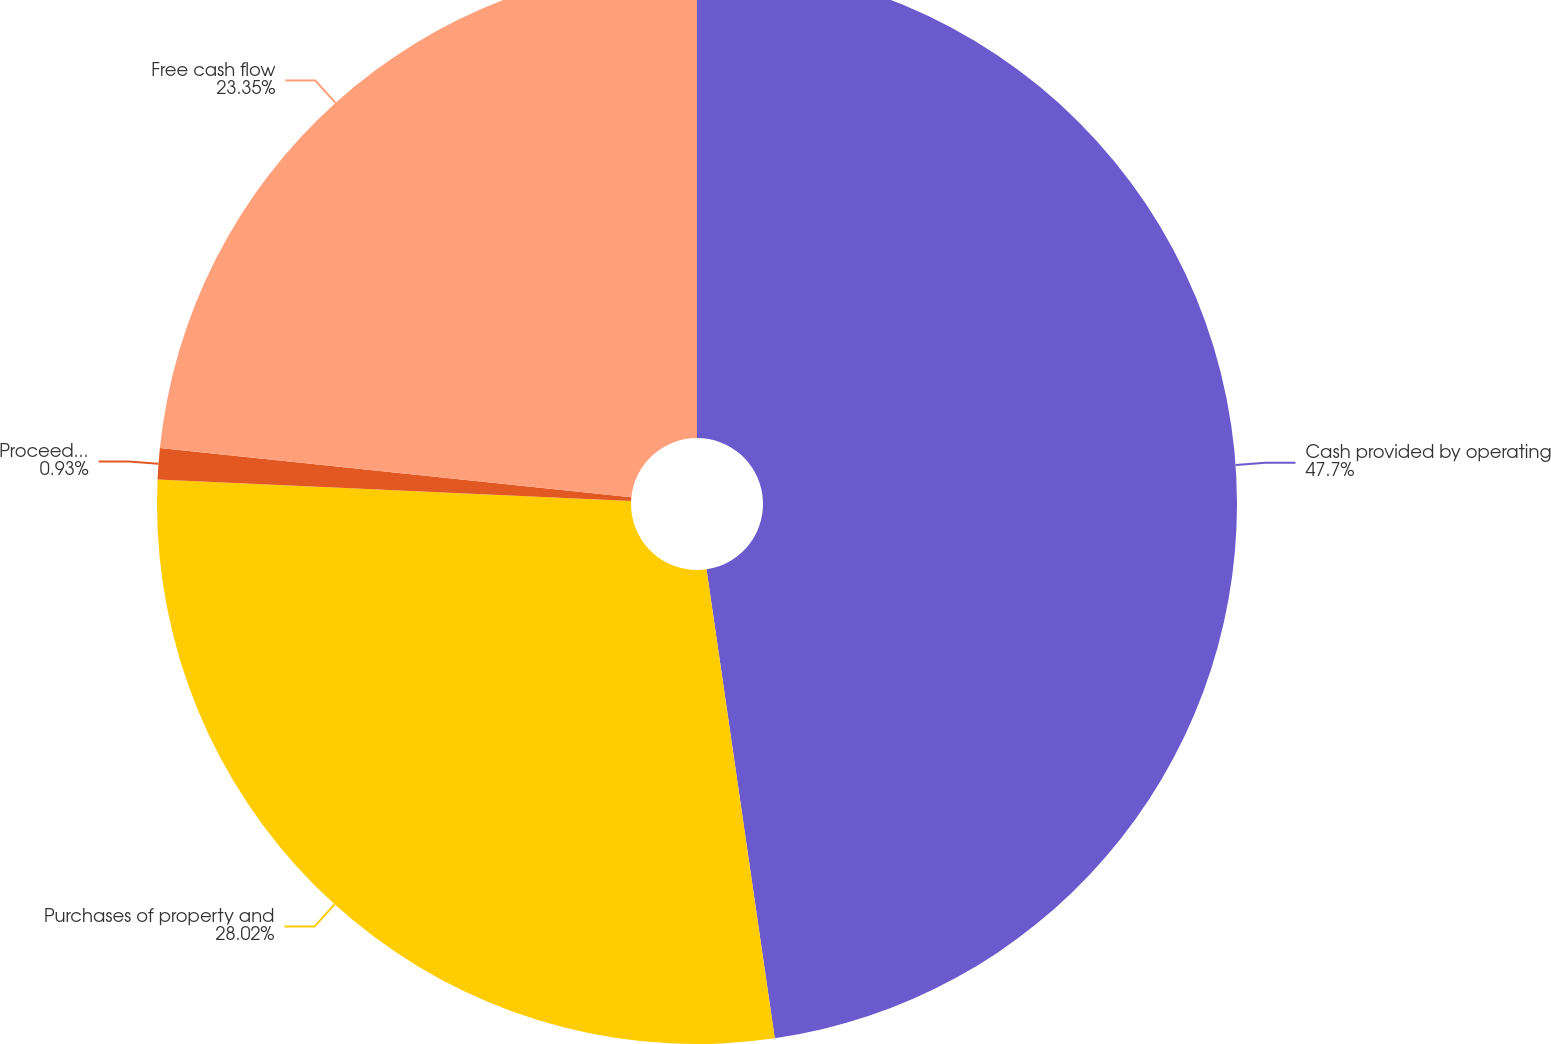Convert chart to OTSL. <chart><loc_0><loc_0><loc_500><loc_500><pie_chart><fcel>Cash provided by operating<fcel>Purchases of property and<fcel>Proceeds from sales of<fcel>Free cash flow<nl><fcel>47.7%<fcel>28.02%<fcel>0.93%<fcel>23.35%<nl></chart> 